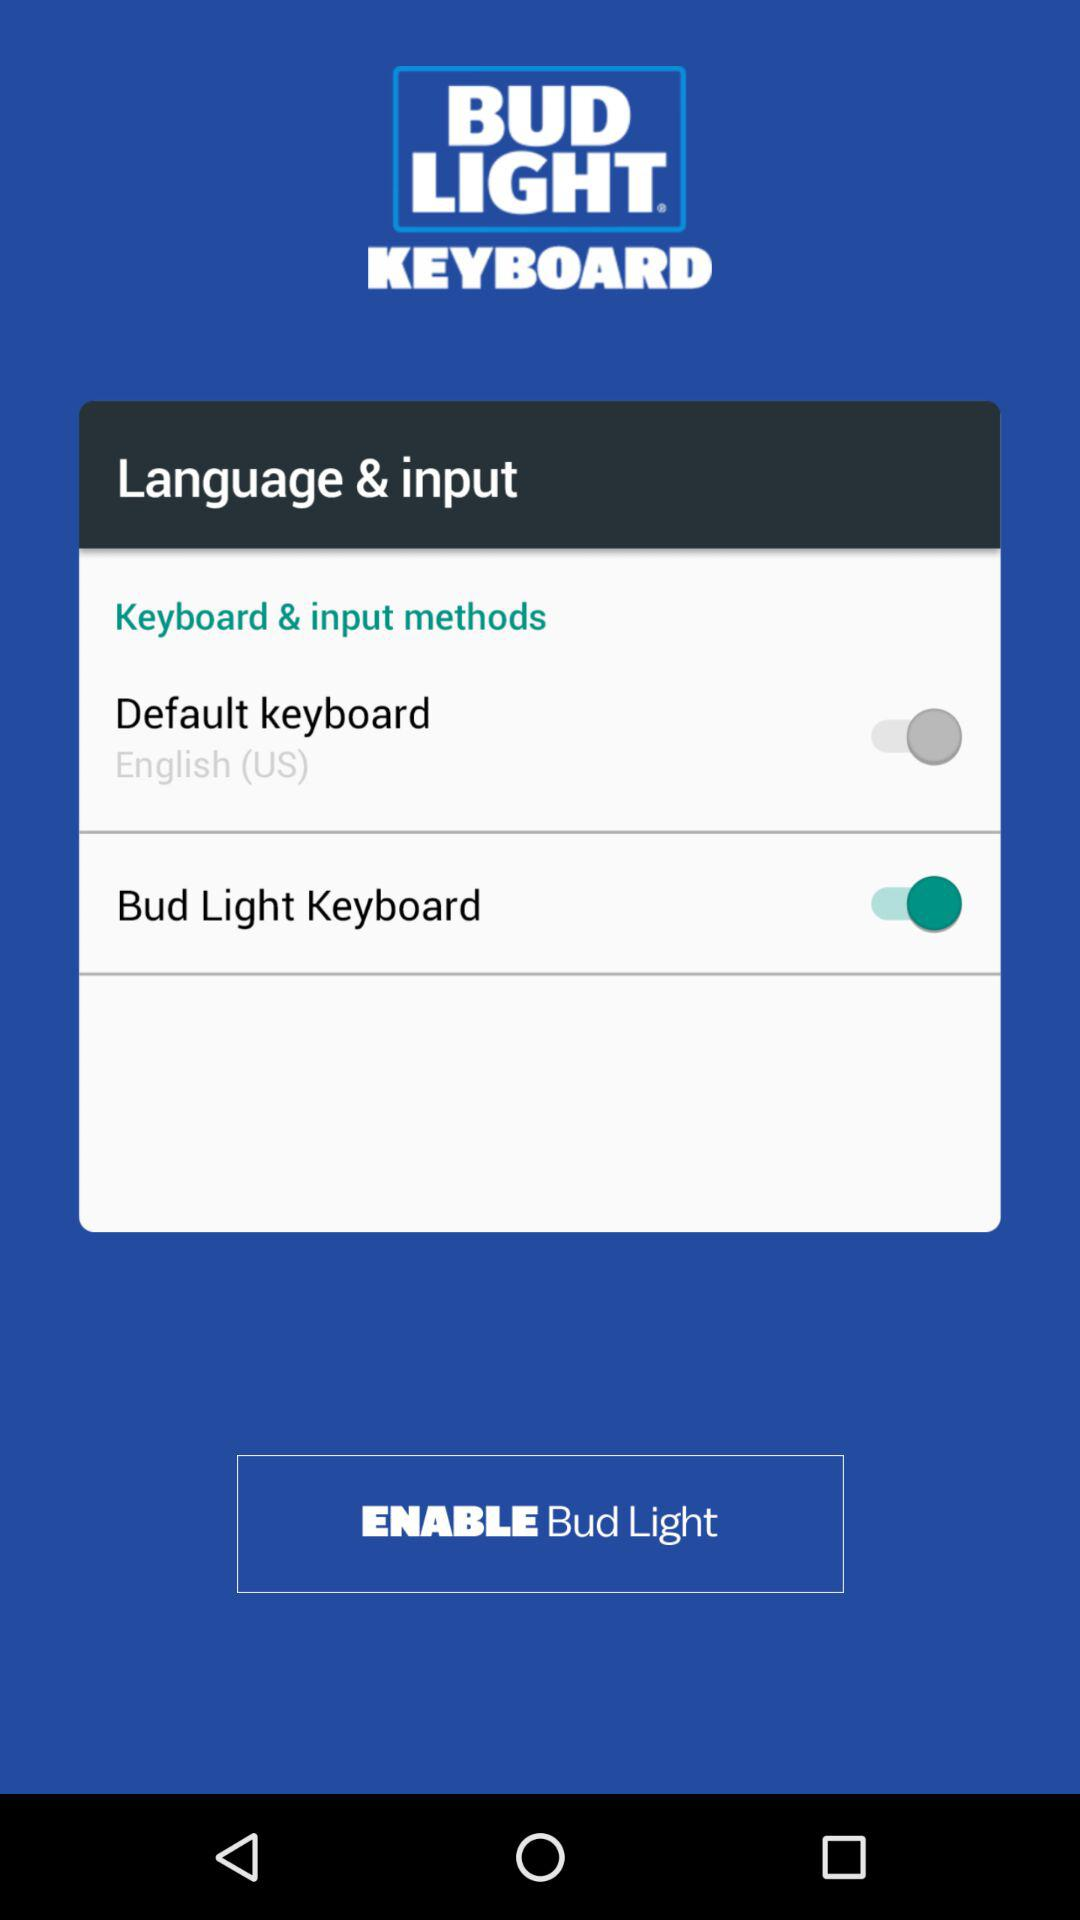What is the status of the "Default keyboard"? The status is "on". 